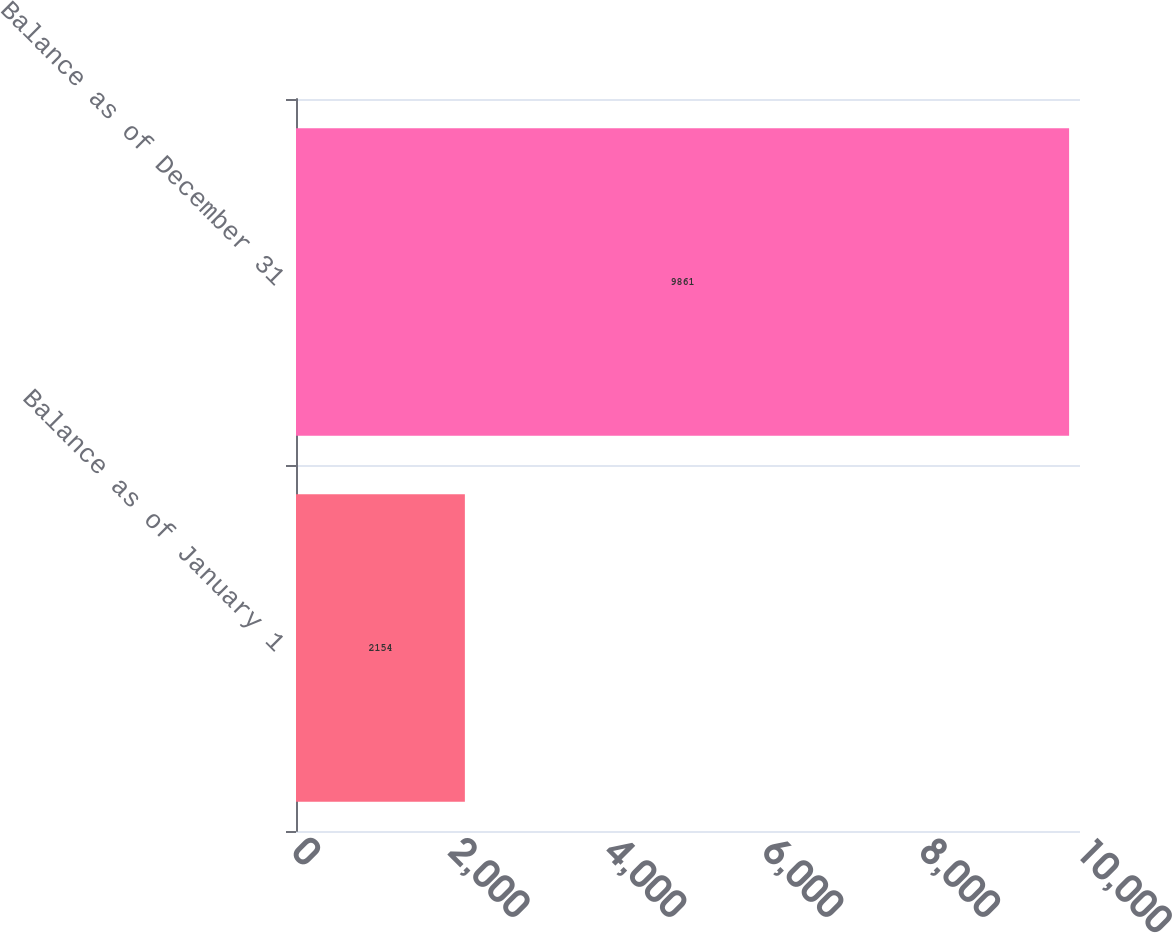<chart> <loc_0><loc_0><loc_500><loc_500><bar_chart><fcel>Balance as of January 1<fcel>Balance as of December 31<nl><fcel>2154<fcel>9861<nl></chart> 